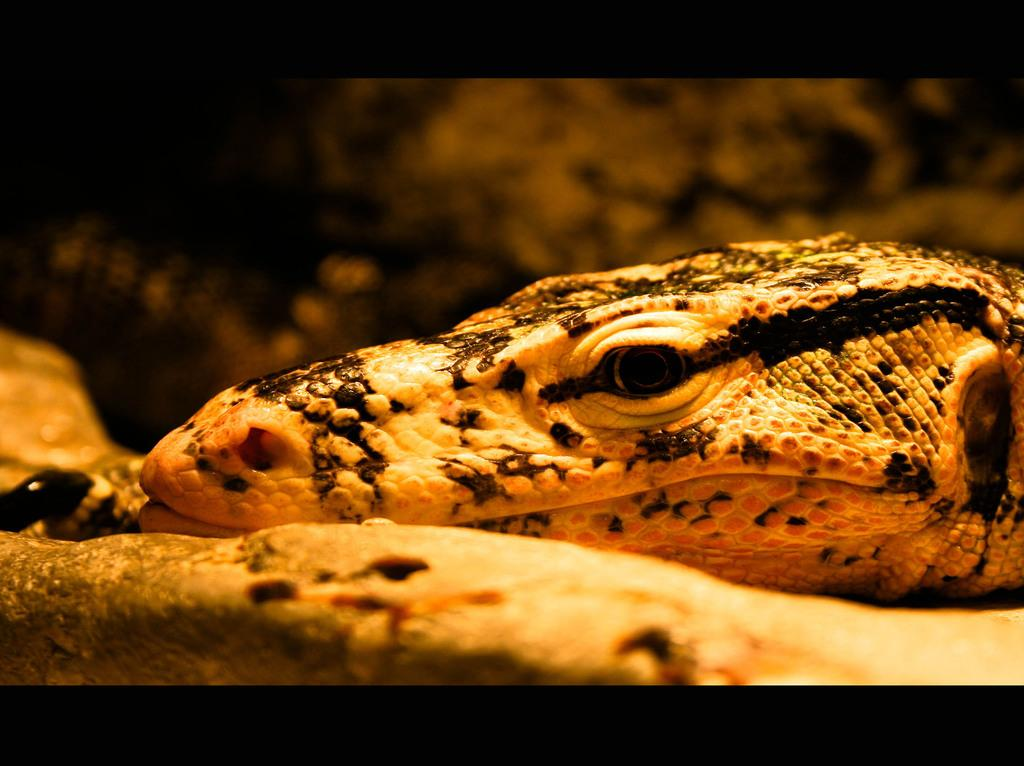What type of creature can be seen in the image? There is an animal in the image. What is the animal doing in the image? The animal is resting its head on a rock. Can you describe the background of the image? The background of the image is blurred. What type of feather can be seen on the animal's head in the image? There is no feather visible on the animal's head in the image. What type of care does the animal require in the image? The image does not provide information about the animal's care needs. 